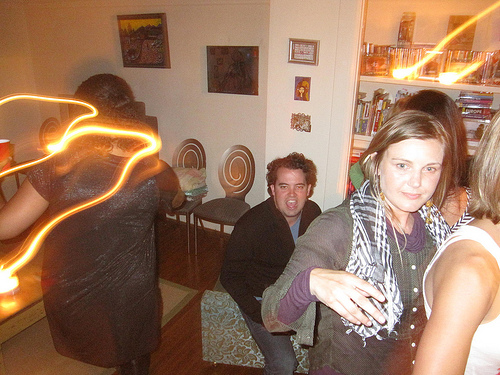<image>
Is the aura in front of the cd collection? No. The aura is not in front of the cd collection. The spatial positioning shows a different relationship between these objects. 